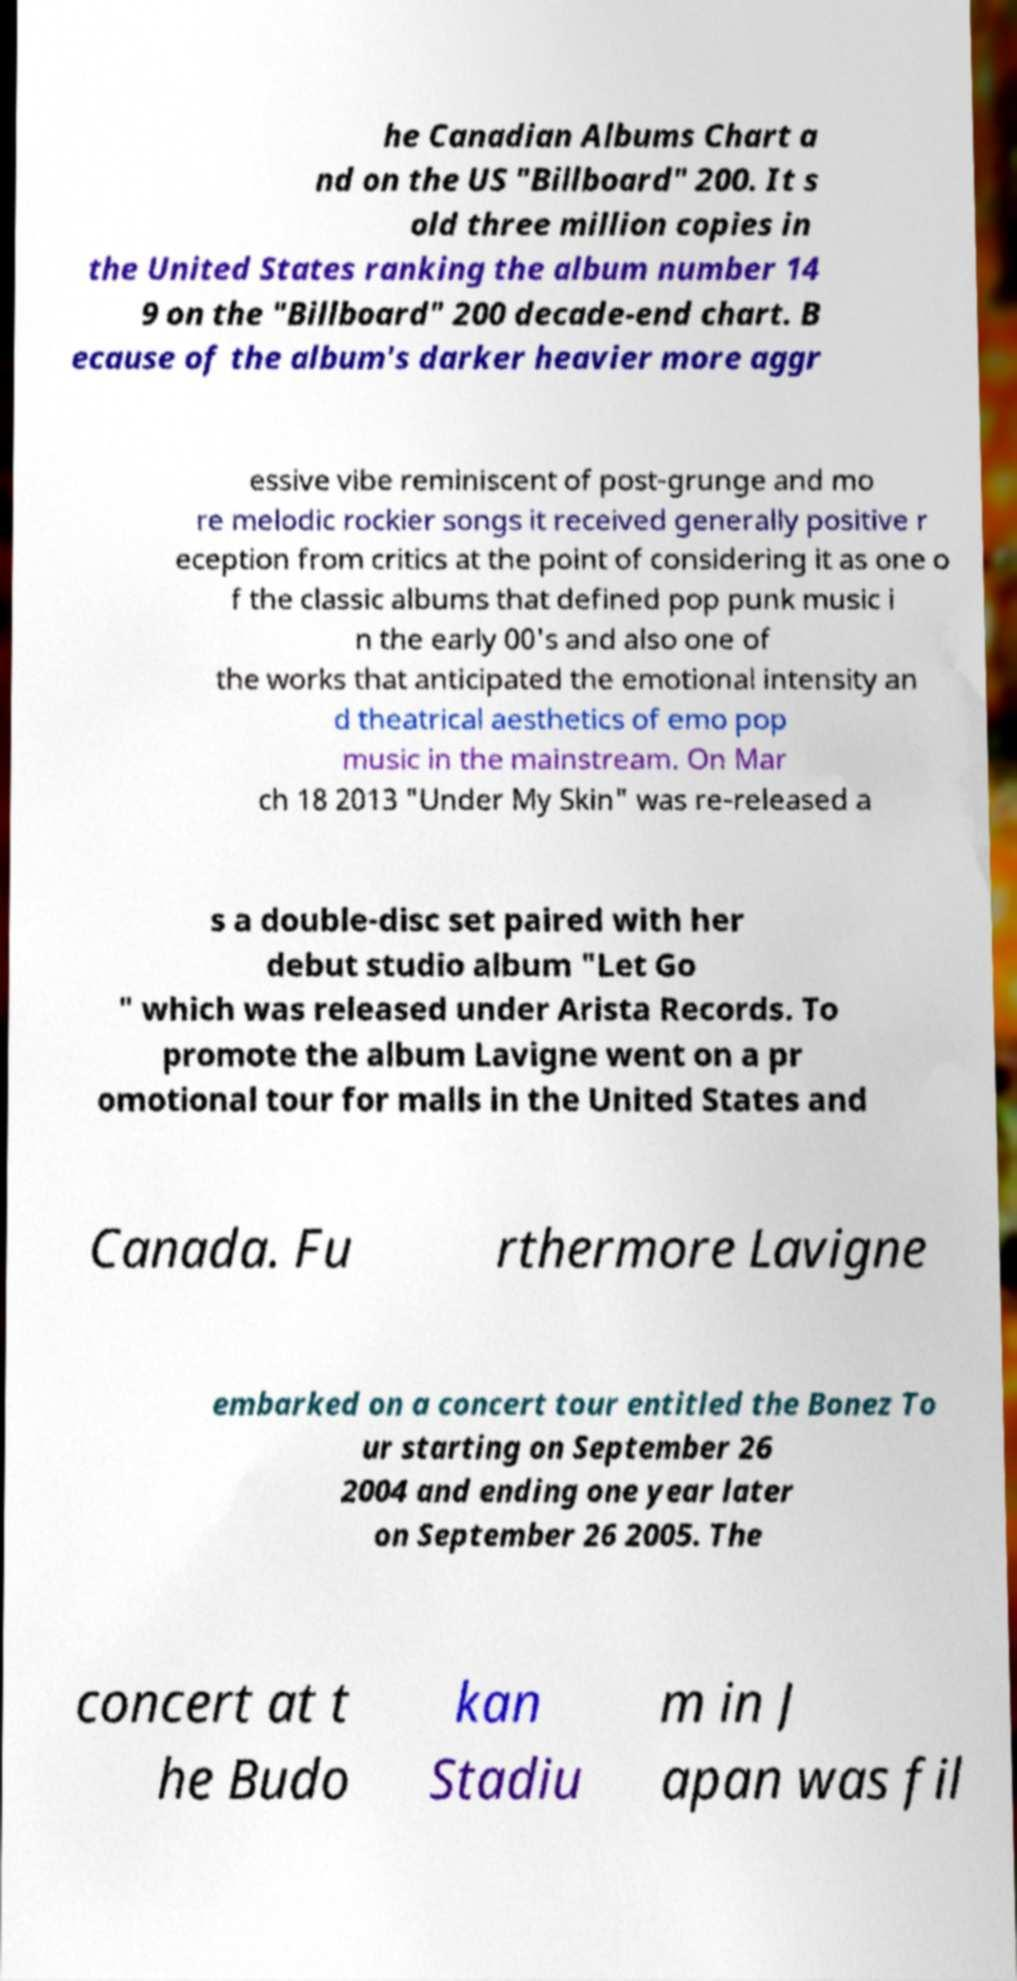There's text embedded in this image that I need extracted. Can you transcribe it verbatim? he Canadian Albums Chart a nd on the US "Billboard" 200. It s old three million copies in the United States ranking the album number 14 9 on the "Billboard" 200 decade-end chart. B ecause of the album's darker heavier more aggr essive vibe reminiscent of post-grunge and mo re melodic rockier songs it received generally positive r eception from critics at the point of considering it as one o f the classic albums that defined pop punk music i n the early 00's and also one of the works that anticipated the emotional intensity an d theatrical aesthetics of emo pop music in the mainstream. On Mar ch 18 2013 "Under My Skin" was re-released a s a double-disc set paired with her debut studio album "Let Go " which was released under Arista Records. To promote the album Lavigne went on a pr omotional tour for malls in the United States and Canada. Fu rthermore Lavigne embarked on a concert tour entitled the Bonez To ur starting on September 26 2004 and ending one year later on September 26 2005. The concert at t he Budo kan Stadiu m in J apan was fil 